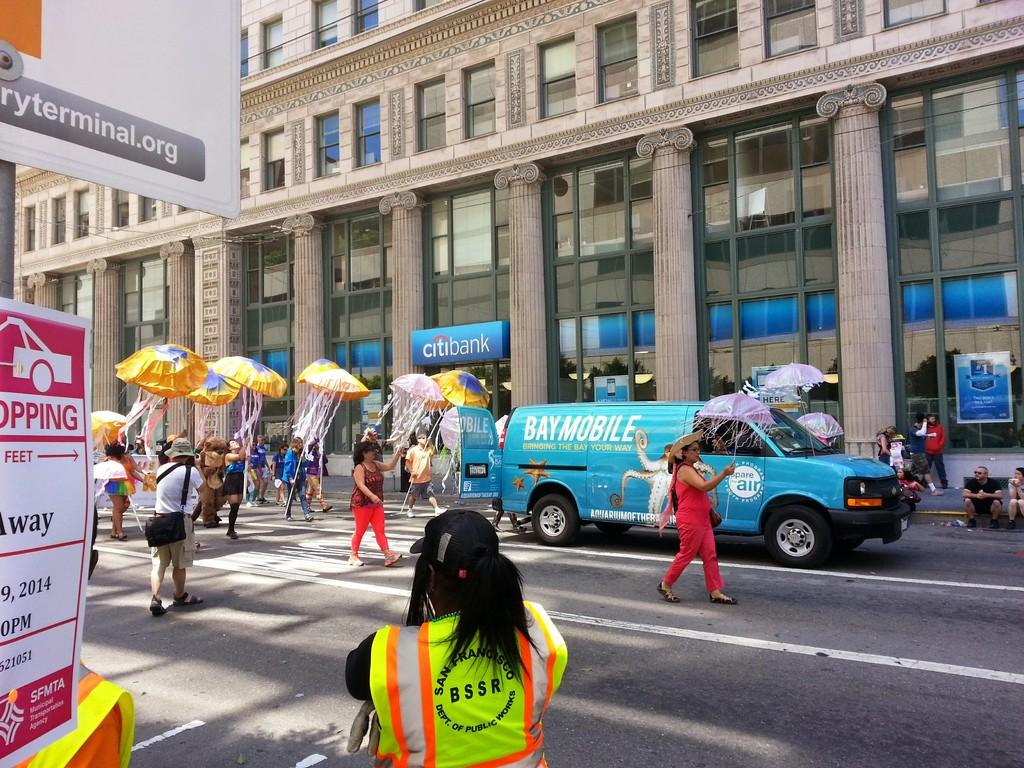<image>
Present a compact description of the photo's key features. a parade marching down a city street in front of a citbank 